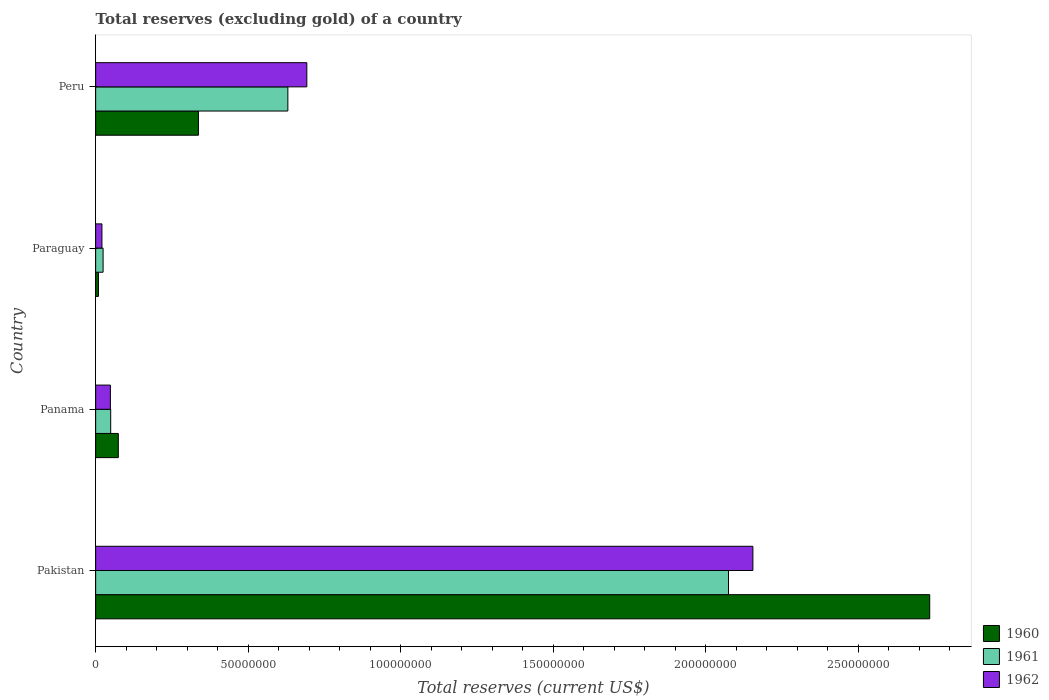How many different coloured bars are there?
Give a very brief answer. 3. Are the number of bars per tick equal to the number of legend labels?
Give a very brief answer. Yes. How many bars are there on the 1st tick from the top?
Ensure brevity in your answer.  3. How many bars are there on the 1st tick from the bottom?
Provide a short and direct response. 3. What is the label of the 2nd group of bars from the top?
Make the answer very short. Paraguay. In how many cases, is the number of bars for a given country not equal to the number of legend labels?
Make the answer very short. 0. What is the total reserves (excluding gold) in 1962 in Panama?
Give a very brief answer. 4.83e+06. Across all countries, what is the maximum total reserves (excluding gold) in 1962?
Your answer should be compact. 2.16e+08. Across all countries, what is the minimum total reserves (excluding gold) in 1962?
Make the answer very short. 2.06e+06. In which country was the total reserves (excluding gold) in 1960 minimum?
Ensure brevity in your answer.  Paraguay. What is the total total reserves (excluding gold) in 1961 in the graph?
Make the answer very short. 2.78e+08. What is the difference between the total reserves (excluding gold) in 1962 in Pakistan and that in Paraguay?
Make the answer very short. 2.13e+08. What is the difference between the total reserves (excluding gold) in 1961 in Peru and the total reserves (excluding gold) in 1962 in Pakistan?
Your answer should be very brief. -1.53e+08. What is the average total reserves (excluding gold) in 1961 per country?
Make the answer very short. 6.95e+07. What is the difference between the total reserves (excluding gold) in 1961 and total reserves (excluding gold) in 1960 in Paraguay?
Provide a short and direct response. 1.53e+06. What is the ratio of the total reserves (excluding gold) in 1961 in Pakistan to that in Peru?
Ensure brevity in your answer.  3.29. Is the difference between the total reserves (excluding gold) in 1961 in Panama and Peru greater than the difference between the total reserves (excluding gold) in 1960 in Panama and Peru?
Make the answer very short. No. What is the difference between the highest and the second highest total reserves (excluding gold) in 1962?
Your answer should be very brief. 1.46e+08. What is the difference between the highest and the lowest total reserves (excluding gold) in 1960?
Ensure brevity in your answer.  2.73e+08. What does the 1st bar from the top in Panama represents?
Your response must be concise. 1962. What does the 1st bar from the bottom in Panama represents?
Ensure brevity in your answer.  1960. Is it the case that in every country, the sum of the total reserves (excluding gold) in 1961 and total reserves (excluding gold) in 1962 is greater than the total reserves (excluding gold) in 1960?
Provide a succinct answer. Yes. How many bars are there?
Provide a short and direct response. 12. How many countries are there in the graph?
Offer a very short reply. 4. Where does the legend appear in the graph?
Provide a succinct answer. Bottom right. What is the title of the graph?
Ensure brevity in your answer.  Total reserves (excluding gold) of a country. Does "2002" appear as one of the legend labels in the graph?
Make the answer very short. No. What is the label or title of the X-axis?
Give a very brief answer. Total reserves (current US$). What is the Total reserves (current US$) of 1960 in Pakistan?
Keep it short and to the point. 2.74e+08. What is the Total reserves (current US$) of 1961 in Pakistan?
Provide a succinct answer. 2.08e+08. What is the Total reserves (current US$) in 1962 in Pakistan?
Offer a very short reply. 2.16e+08. What is the Total reserves (current US$) in 1960 in Panama?
Ensure brevity in your answer.  7.43e+06. What is the Total reserves (current US$) in 1961 in Panama?
Provide a succinct answer. 4.93e+06. What is the Total reserves (current US$) in 1962 in Panama?
Your answer should be compact. 4.83e+06. What is the Total reserves (current US$) of 1960 in Paraguay?
Provide a short and direct response. 9.10e+05. What is the Total reserves (current US$) of 1961 in Paraguay?
Ensure brevity in your answer.  2.44e+06. What is the Total reserves (current US$) in 1962 in Paraguay?
Make the answer very short. 2.06e+06. What is the Total reserves (current US$) of 1960 in Peru?
Keep it short and to the point. 3.37e+07. What is the Total reserves (current US$) in 1961 in Peru?
Your response must be concise. 6.30e+07. What is the Total reserves (current US$) in 1962 in Peru?
Your response must be concise. 6.92e+07. Across all countries, what is the maximum Total reserves (current US$) of 1960?
Keep it short and to the point. 2.74e+08. Across all countries, what is the maximum Total reserves (current US$) in 1961?
Provide a short and direct response. 2.08e+08. Across all countries, what is the maximum Total reserves (current US$) of 1962?
Offer a very short reply. 2.16e+08. Across all countries, what is the minimum Total reserves (current US$) in 1960?
Offer a very short reply. 9.10e+05. Across all countries, what is the minimum Total reserves (current US$) of 1961?
Make the answer very short. 2.44e+06. Across all countries, what is the minimum Total reserves (current US$) of 1962?
Your answer should be compact. 2.06e+06. What is the total Total reserves (current US$) in 1960 in the graph?
Your response must be concise. 3.16e+08. What is the total Total reserves (current US$) of 1961 in the graph?
Your answer should be very brief. 2.78e+08. What is the total Total reserves (current US$) of 1962 in the graph?
Your answer should be compact. 2.92e+08. What is the difference between the Total reserves (current US$) in 1960 in Pakistan and that in Panama?
Keep it short and to the point. 2.66e+08. What is the difference between the Total reserves (current US$) in 1961 in Pakistan and that in Panama?
Your answer should be very brief. 2.03e+08. What is the difference between the Total reserves (current US$) in 1962 in Pakistan and that in Panama?
Offer a terse response. 2.11e+08. What is the difference between the Total reserves (current US$) of 1960 in Pakistan and that in Paraguay?
Provide a short and direct response. 2.73e+08. What is the difference between the Total reserves (current US$) of 1961 in Pakistan and that in Paraguay?
Provide a short and direct response. 2.05e+08. What is the difference between the Total reserves (current US$) in 1962 in Pakistan and that in Paraguay?
Offer a very short reply. 2.13e+08. What is the difference between the Total reserves (current US$) in 1960 in Pakistan and that in Peru?
Provide a short and direct response. 2.40e+08. What is the difference between the Total reserves (current US$) of 1961 in Pakistan and that in Peru?
Make the answer very short. 1.45e+08. What is the difference between the Total reserves (current US$) in 1962 in Pakistan and that in Peru?
Offer a very short reply. 1.46e+08. What is the difference between the Total reserves (current US$) of 1960 in Panama and that in Paraguay?
Keep it short and to the point. 6.52e+06. What is the difference between the Total reserves (current US$) in 1961 in Panama and that in Paraguay?
Offer a terse response. 2.49e+06. What is the difference between the Total reserves (current US$) in 1962 in Panama and that in Paraguay?
Provide a short and direct response. 2.77e+06. What is the difference between the Total reserves (current US$) of 1960 in Panama and that in Peru?
Provide a short and direct response. -2.63e+07. What is the difference between the Total reserves (current US$) in 1961 in Panama and that in Peru?
Your response must be concise. -5.81e+07. What is the difference between the Total reserves (current US$) of 1962 in Panama and that in Peru?
Your response must be concise. -6.44e+07. What is the difference between the Total reserves (current US$) of 1960 in Paraguay and that in Peru?
Give a very brief answer. -3.28e+07. What is the difference between the Total reserves (current US$) of 1961 in Paraguay and that in Peru?
Offer a very short reply. -6.06e+07. What is the difference between the Total reserves (current US$) of 1962 in Paraguay and that in Peru?
Your answer should be very brief. -6.72e+07. What is the difference between the Total reserves (current US$) in 1960 in Pakistan and the Total reserves (current US$) in 1961 in Panama?
Offer a terse response. 2.69e+08. What is the difference between the Total reserves (current US$) of 1960 in Pakistan and the Total reserves (current US$) of 1962 in Panama?
Make the answer very short. 2.69e+08. What is the difference between the Total reserves (current US$) of 1961 in Pakistan and the Total reserves (current US$) of 1962 in Panama?
Provide a short and direct response. 2.03e+08. What is the difference between the Total reserves (current US$) of 1960 in Pakistan and the Total reserves (current US$) of 1961 in Paraguay?
Give a very brief answer. 2.71e+08. What is the difference between the Total reserves (current US$) of 1960 in Pakistan and the Total reserves (current US$) of 1962 in Paraguay?
Provide a succinct answer. 2.71e+08. What is the difference between the Total reserves (current US$) of 1961 in Pakistan and the Total reserves (current US$) of 1962 in Paraguay?
Give a very brief answer. 2.05e+08. What is the difference between the Total reserves (current US$) in 1960 in Pakistan and the Total reserves (current US$) in 1961 in Peru?
Your response must be concise. 2.10e+08. What is the difference between the Total reserves (current US$) in 1960 in Pakistan and the Total reserves (current US$) in 1962 in Peru?
Ensure brevity in your answer.  2.04e+08. What is the difference between the Total reserves (current US$) of 1961 in Pakistan and the Total reserves (current US$) of 1962 in Peru?
Make the answer very short. 1.38e+08. What is the difference between the Total reserves (current US$) in 1960 in Panama and the Total reserves (current US$) in 1961 in Paraguay?
Your answer should be very brief. 4.99e+06. What is the difference between the Total reserves (current US$) of 1960 in Panama and the Total reserves (current US$) of 1962 in Paraguay?
Keep it short and to the point. 5.37e+06. What is the difference between the Total reserves (current US$) of 1961 in Panama and the Total reserves (current US$) of 1962 in Paraguay?
Provide a short and direct response. 2.87e+06. What is the difference between the Total reserves (current US$) of 1960 in Panama and the Total reserves (current US$) of 1961 in Peru?
Give a very brief answer. -5.56e+07. What is the difference between the Total reserves (current US$) in 1960 in Panama and the Total reserves (current US$) in 1962 in Peru?
Offer a terse response. -6.18e+07. What is the difference between the Total reserves (current US$) of 1961 in Panama and the Total reserves (current US$) of 1962 in Peru?
Your answer should be compact. -6.43e+07. What is the difference between the Total reserves (current US$) of 1960 in Paraguay and the Total reserves (current US$) of 1961 in Peru?
Offer a very short reply. -6.21e+07. What is the difference between the Total reserves (current US$) in 1960 in Paraguay and the Total reserves (current US$) in 1962 in Peru?
Give a very brief answer. -6.83e+07. What is the difference between the Total reserves (current US$) of 1961 in Paraguay and the Total reserves (current US$) of 1962 in Peru?
Your answer should be compact. -6.68e+07. What is the average Total reserves (current US$) of 1960 per country?
Offer a very short reply. 7.89e+07. What is the average Total reserves (current US$) in 1961 per country?
Keep it short and to the point. 6.95e+07. What is the average Total reserves (current US$) of 1962 per country?
Give a very brief answer. 7.29e+07. What is the difference between the Total reserves (current US$) of 1960 and Total reserves (current US$) of 1961 in Pakistan?
Your answer should be compact. 6.60e+07. What is the difference between the Total reserves (current US$) in 1960 and Total reserves (current US$) in 1962 in Pakistan?
Provide a succinct answer. 5.80e+07. What is the difference between the Total reserves (current US$) in 1961 and Total reserves (current US$) in 1962 in Pakistan?
Your answer should be very brief. -8.00e+06. What is the difference between the Total reserves (current US$) of 1960 and Total reserves (current US$) of 1961 in Panama?
Ensure brevity in your answer.  2.50e+06. What is the difference between the Total reserves (current US$) in 1960 and Total reserves (current US$) in 1962 in Panama?
Offer a terse response. 2.60e+06. What is the difference between the Total reserves (current US$) in 1960 and Total reserves (current US$) in 1961 in Paraguay?
Ensure brevity in your answer.  -1.53e+06. What is the difference between the Total reserves (current US$) of 1960 and Total reserves (current US$) of 1962 in Paraguay?
Your answer should be very brief. -1.15e+06. What is the difference between the Total reserves (current US$) of 1961 and Total reserves (current US$) of 1962 in Paraguay?
Offer a very short reply. 3.80e+05. What is the difference between the Total reserves (current US$) in 1960 and Total reserves (current US$) in 1961 in Peru?
Provide a succinct answer. -2.93e+07. What is the difference between the Total reserves (current US$) of 1960 and Total reserves (current US$) of 1962 in Peru?
Provide a short and direct response. -3.55e+07. What is the difference between the Total reserves (current US$) of 1961 and Total reserves (current US$) of 1962 in Peru?
Offer a terse response. -6.22e+06. What is the ratio of the Total reserves (current US$) in 1960 in Pakistan to that in Panama?
Your answer should be very brief. 36.81. What is the ratio of the Total reserves (current US$) of 1961 in Pakistan to that in Panama?
Your answer should be compact. 42.1. What is the ratio of the Total reserves (current US$) of 1962 in Pakistan to that in Panama?
Keep it short and to the point. 44.62. What is the ratio of the Total reserves (current US$) in 1960 in Pakistan to that in Paraguay?
Give a very brief answer. 300.57. What is the ratio of the Total reserves (current US$) of 1961 in Pakistan to that in Paraguay?
Keep it short and to the point. 85.05. What is the ratio of the Total reserves (current US$) in 1962 in Pakistan to that in Paraguay?
Provide a short and direct response. 104.63. What is the ratio of the Total reserves (current US$) in 1960 in Pakistan to that in Peru?
Provide a succinct answer. 8.12. What is the ratio of the Total reserves (current US$) of 1961 in Pakistan to that in Peru?
Offer a very short reply. 3.29. What is the ratio of the Total reserves (current US$) of 1962 in Pakistan to that in Peru?
Your response must be concise. 3.11. What is the ratio of the Total reserves (current US$) in 1960 in Panama to that in Paraguay?
Make the answer very short. 8.16. What is the ratio of the Total reserves (current US$) in 1961 in Panama to that in Paraguay?
Make the answer very short. 2.02. What is the ratio of the Total reserves (current US$) of 1962 in Panama to that in Paraguay?
Your answer should be compact. 2.34. What is the ratio of the Total reserves (current US$) of 1960 in Panama to that in Peru?
Provide a short and direct response. 0.22. What is the ratio of the Total reserves (current US$) in 1961 in Panama to that in Peru?
Give a very brief answer. 0.08. What is the ratio of the Total reserves (current US$) of 1962 in Panama to that in Peru?
Offer a very short reply. 0.07. What is the ratio of the Total reserves (current US$) of 1960 in Paraguay to that in Peru?
Provide a succinct answer. 0.03. What is the ratio of the Total reserves (current US$) of 1961 in Paraguay to that in Peru?
Offer a terse response. 0.04. What is the ratio of the Total reserves (current US$) in 1962 in Paraguay to that in Peru?
Your response must be concise. 0.03. What is the difference between the highest and the second highest Total reserves (current US$) in 1960?
Offer a terse response. 2.40e+08. What is the difference between the highest and the second highest Total reserves (current US$) of 1961?
Make the answer very short. 1.45e+08. What is the difference between the highest and the second highest Total reserves (current US$) of 1962?
Keep it short and to the point. 1.46e+08. What is the difference between the highest and the lowest Total reserves (current US$) of 1960?
Ensure brevity in your answer.  2.73e+08. What is the difference between the highest and the lowest Total reserves (current US$) of 1961?
Your response must be concise. 2.05e+08. What is the difference between the highest and the lowest Total reserves (current US$) of 1962?
Your response must be concise. 2.13e+08. 